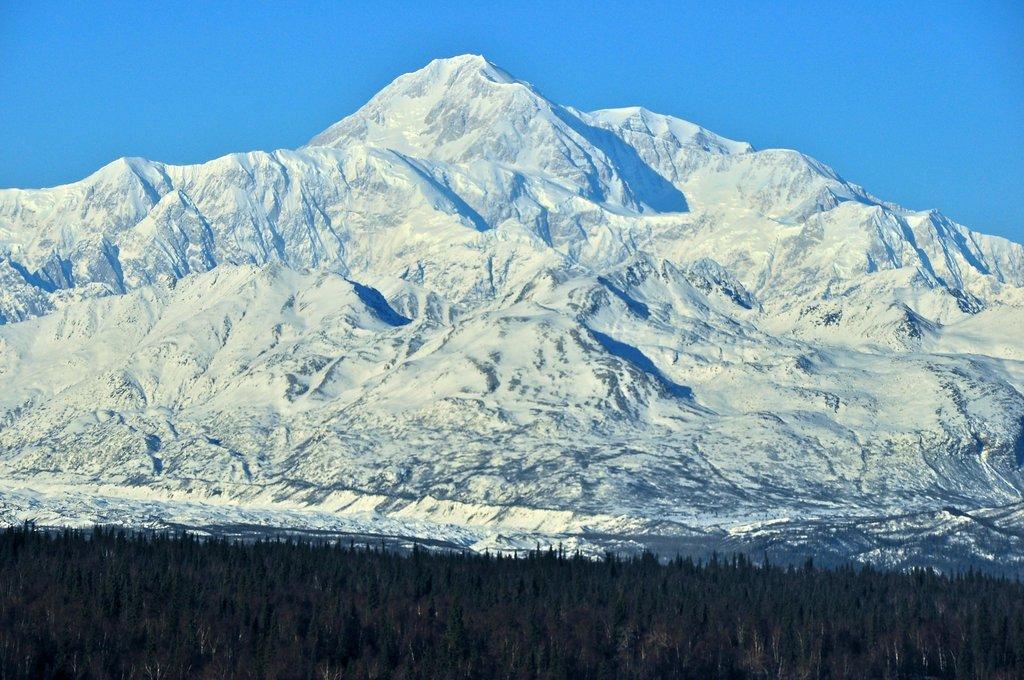Can you describe this image briefly? In this picture we can see trees and snowy mountains. In the background of the image we can see the sky in blue color. 